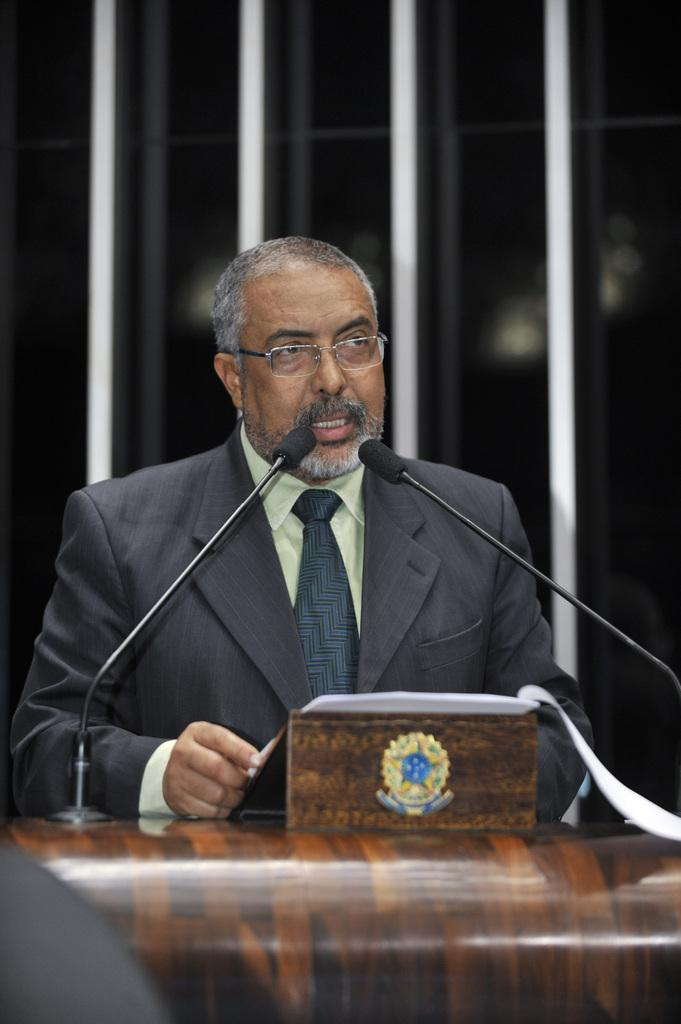Who is the main subject in the image? There is a man in the image. What is the man doing in the image? The man is standing at a podium and speaking. What objects are present in the image that might be related to the man's speaking? Microphones are present in the image. What is the man holding in his hands? The man is holding papers in his hands. Can you describe the man's attire in the image? The man is wearing spectacles, a coat, and a tie. What type of yam is the man holding in the image? There is no yam present in the image; the man is holding papers in his hands. 